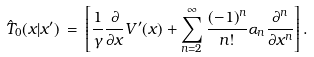<formula> <loc_0><loc_0><loc_500><loc_500>\hat { T } _ { 0 } ( x | x ^ { \prime } ) \, = \, \left [ \frac { 1 } { \gamma } \frac { \partial } { \partial x } V ^ { \prime } ( x ) + \sum _ { n = 2 } ^ { \infty } \frac { ( - 1 ) ^ { n } } { n ! } \alpha _ { n } \frac { \partial ^ { n } } { \partial x ^ { n } } \right ] .</formula> 